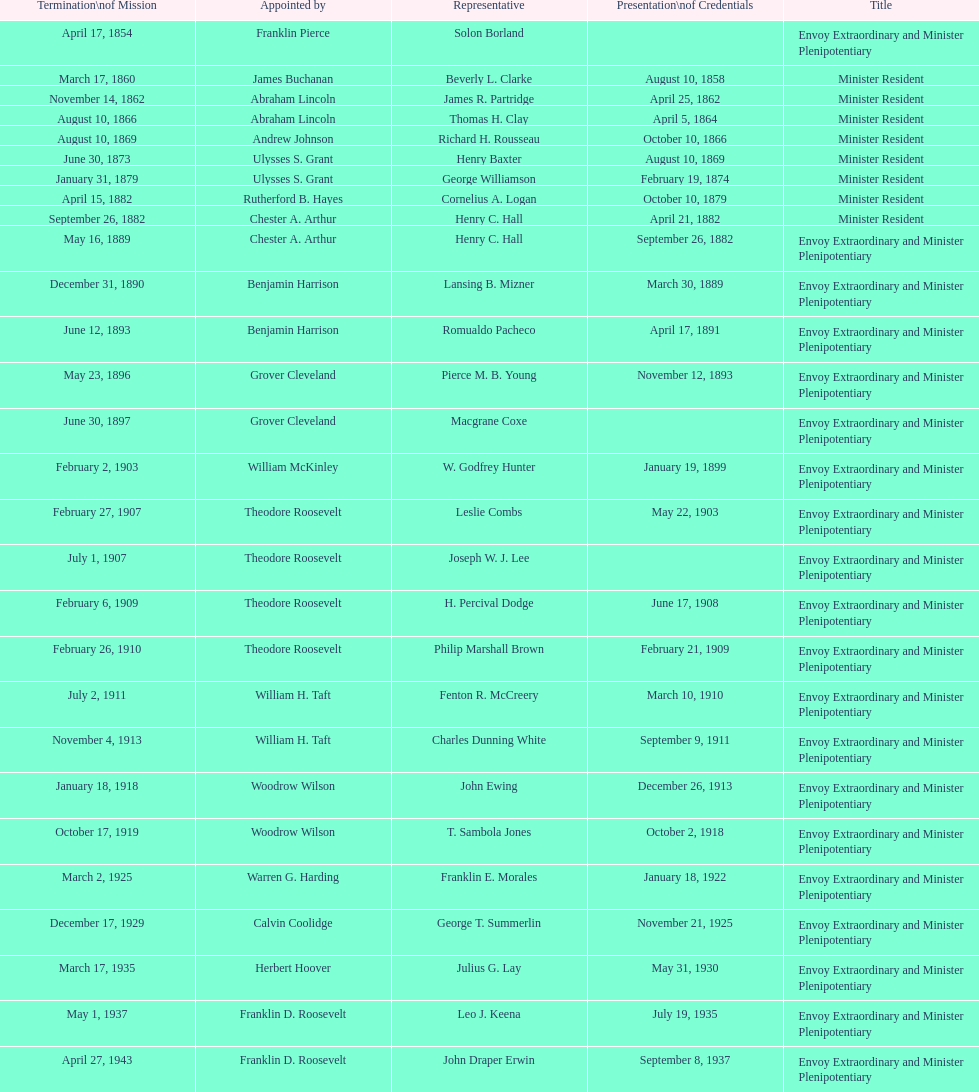Who was the last representative picked? Lisa Kubiske. 